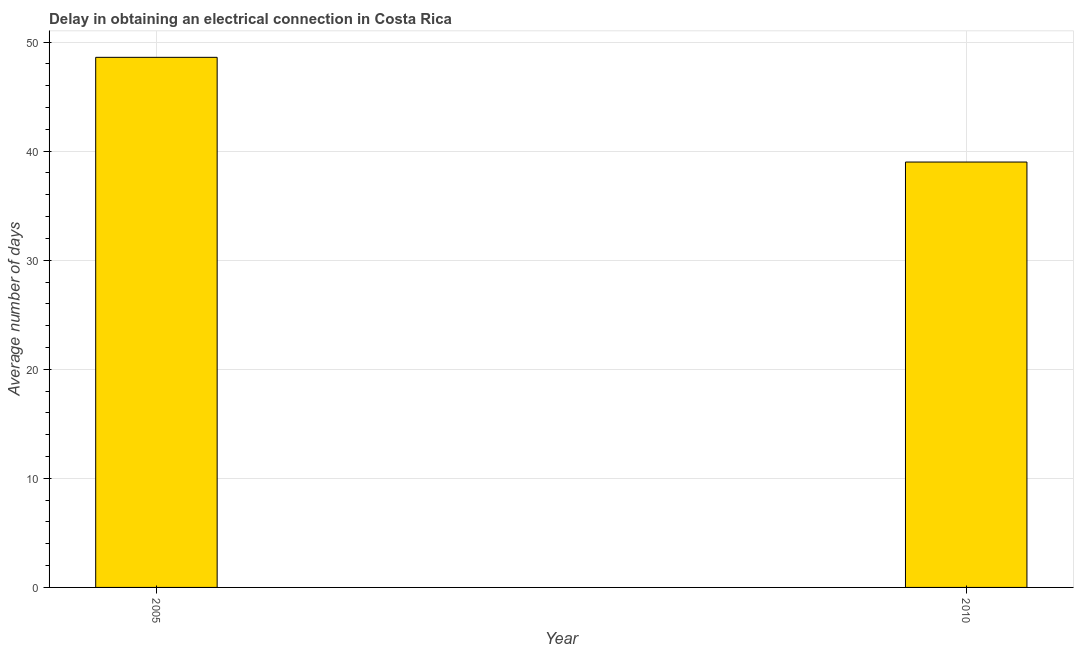Does the graph contain any zero values?
Provide a short and direct response. No. Does the graph contain grids?
Ensure brevity in your answer.  Yes. What is the title of the graph?
Your answer should be compact. Delay in obtaining an electrical connection in Costa Rica. What is the label or title of the X-axis?
Make the answer very short. Year. What is the label or title of the Y-axis?
Keep it short and to the point. Average number of days. What is the dalay in electrical connection in 2010?
Your answer should be compact. 39. Across all years, what is the maximum dalay in electrical connection?
Keep it short and to the point. 48.6. In which year was the dalay in electrical connection minimum?
Provide a short and direct response. 2010. What is the sum of the dalay in electrical connection?
Make the answer very short. 87.6. What is the average dalay in electrical connection per year?
Your answer should be compact. 43.8. What is the median dalay in electrical connection?
Keep it short and to the point. 43.8. Do a majority of the years between 2010 and 2005 (inclusive) have dalay in electrical connection greater than 8 days?
Make the answer very short. No. What is the ratio of the dalay in electrical connection in 2005 to that in 2010?
Keep it short and to the point. 1.25. Is the dalay in electrical connection in 2005 less than that in 2010?
Provide a short and direct response. No. How many bars are there?
Make the answer very short. 2. Are all the bars in the graph horizontal?
Your answer should be very brief. No. How many years are there in the graph?
Offer a very short reply. 2. What is the Average number of days of 2005?
Give a very brief answer. 48.6. What is the difference between the Average number of days in 2005 and 2010?
Provide a succinct answer. 9.6. What is the ratio of the Average number of days in 2005 to that in 2010?
Provide a succinct answer. 1.25. 